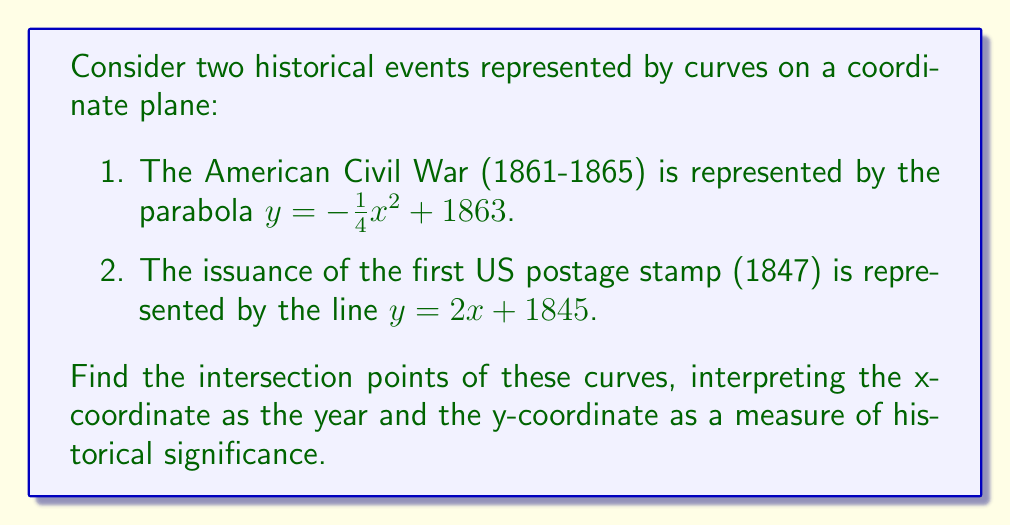Provide a solution to this math problem. To find the intersection points, we need to solve the system of equations:

$$y = -\frac{1}{4}x^2 + 1863$$
$$y = 2x + 1845$$

Step 1: Set the equations equal to each other
$$-\frac{1}{4}x^2 + 1863 = 2x + 1845$$

Step 2: Rearrange the equation to standard quadratic form
$$-\frac{1}{4}x^2 - 2x + 18 = 0$$

Step 3: Multiply all terms by -4 to simplify
$$x^2 + 8x - 72 = 0$$

Step 4: Use the quadratic formula $x = \frac{-b \pm \sqrt{b^2 - 4ac}}{2a}$
Where $a=1$, $b=8$, and $c=-72$

$$x = \frac{-8 \pm \sqrt{8^2 - 4(1)(-72)}}{2(1)}$$
$$x = \frac{-8 \pm \sqrt{64 + 288}}{2}$$
$$x = \frac{-8 \pm \sqrt{352}}{2}$$
$$x = \frac{-8 \pm 18.76}{2}$$

Step 5: Solve for the two x values
$$x_1 = \frac{-8 + 18.76}{2} = 5.38$$
$$x_2 = \frac{-8 - 18.76}{2} = -13.38$$

Step 6: Find the corresponding y values by substituting x into either original equation
For $x_1 = 5.38$:
$$y_1 = 2(5.38) + 1845 = 1855.76$$

For $x_2 = -13.38$:
$$y_2 = 2(-13.38) + 1845 = 1818.24$$

Step 7: Interpret the results
The valid intersection point is (5.38, 1855.76), as it falls within the timeframe of both events. This corresponds to the year 1855 (rounding 1855.38 to the nearest integer).
Answer: (5.38, 1855.76), representing the year 1855 